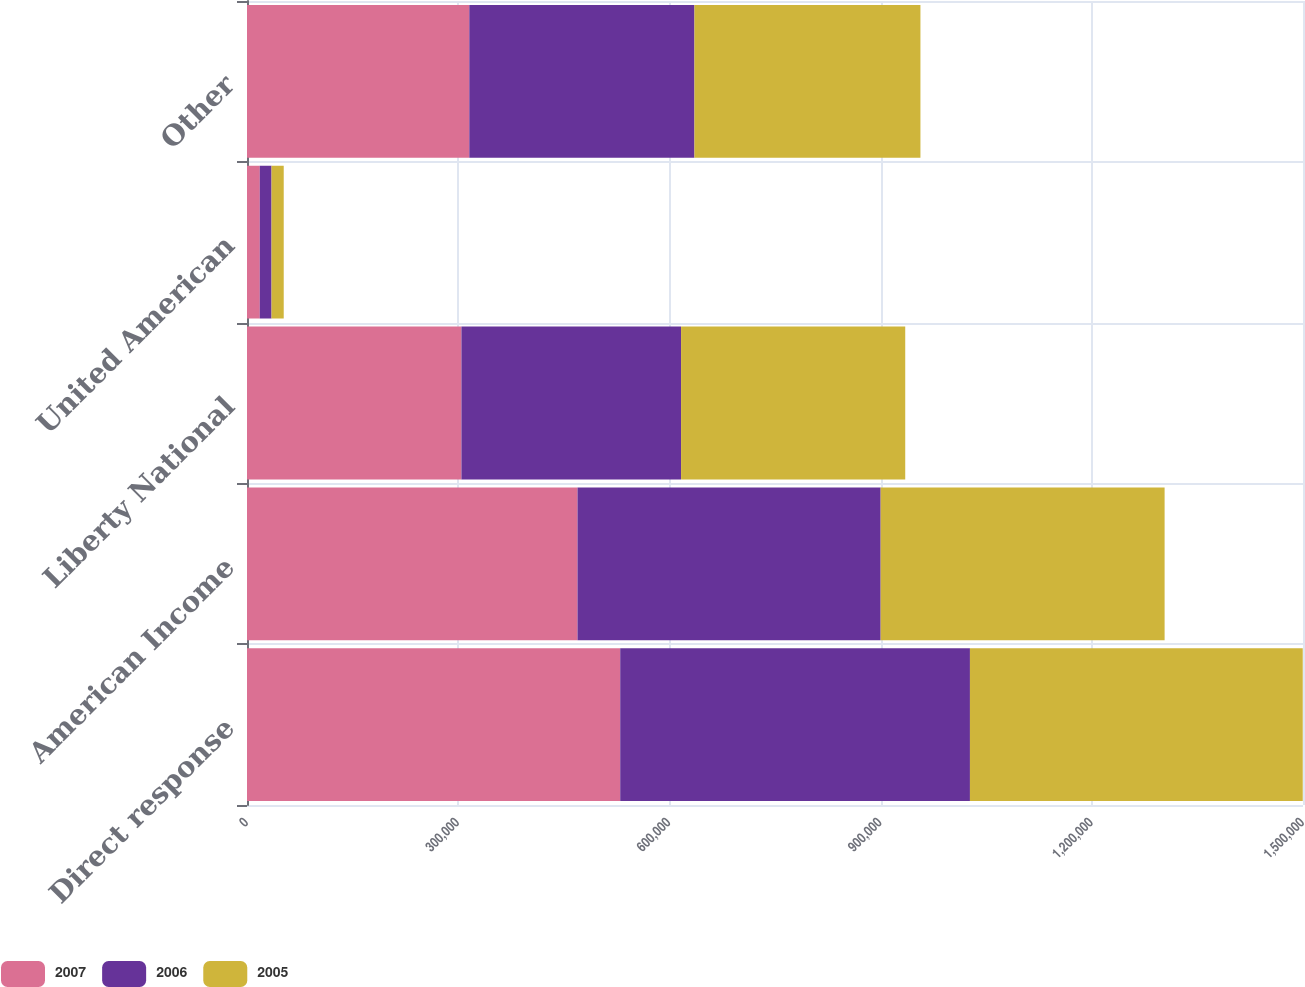<chart> <loc_0><loc_0><loc_500><loc_500><stacked_bar_chart><ecel><fcel>Direct response<fcel>American Income<fcel>Liberty National<fcel>United American<fcel>Other<nl><fcel>2007<fcel>530137<fcel>469486<fcel>304584<fcel>18140<fcel>315760<nl><fcel>2006<fcel>496772<fcel>430598<fcel>311975<fcel>16710<fcel>319819<nl><fcel>2005<fcel>472733<fcel>403333<fcel>318435<fcel>17315<fcel>321000<nl></chart> 